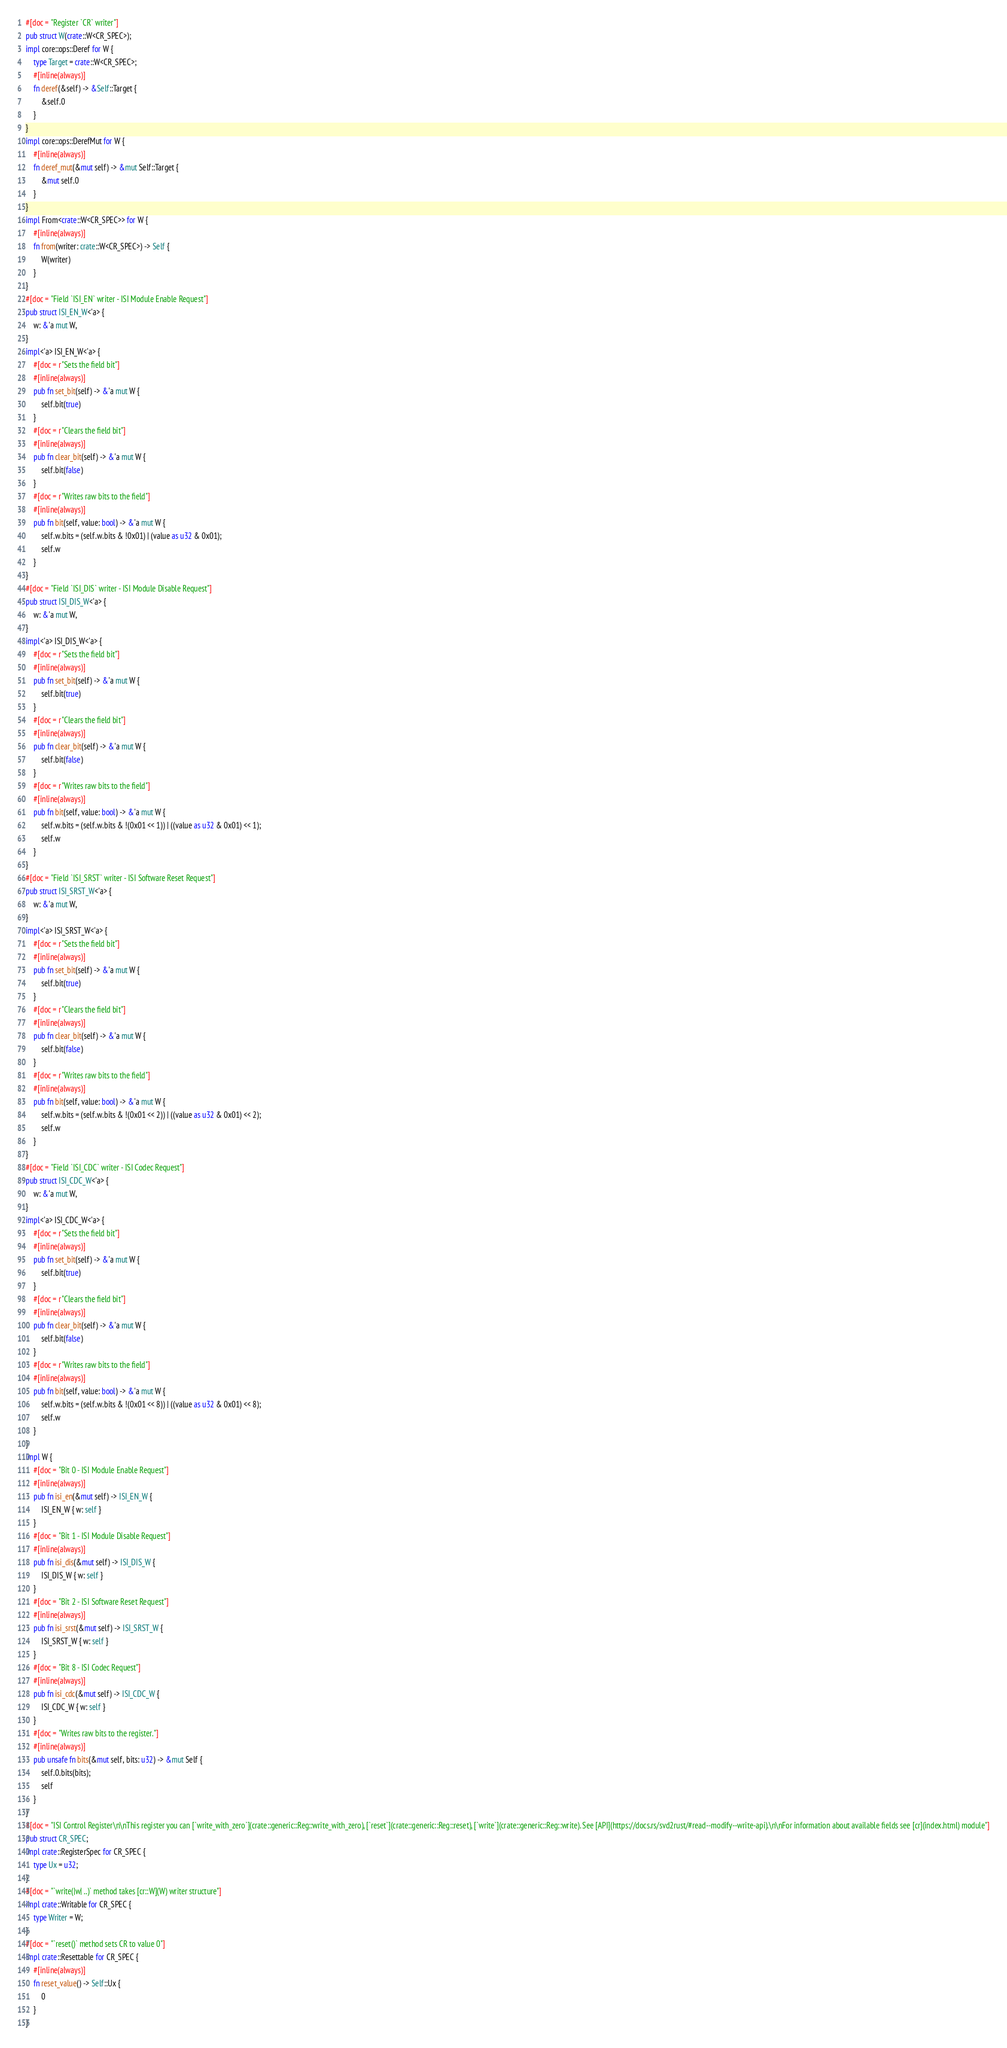<code> <loc_0><loc_0><loc_500><loc_500><_Rust_>#[doc = "Register `CR` writer"]
pub struct W(crate::W<CR_SPEC>);
impl core::ops::Deref for W {
    type Target = crate::W<CR_SPEC>;
    #[inline(always)]
    fn deref(&self) -> &Self::Target {
        &self.0
    }
}
impl core::ops::DerefMut for W {
    #[inline(always)]
    fn deref_mut(&mut self) -> &mut Self::Target {
        &mut self.0
    }
}
impl From<crate::W<CR_SPEC>> for W {
    #[inline(always)]
    fn from(writer: crate::W<CR_SPEC>) -> Self {
        W(writer)
    }
}
#[doc = "Field `ISI_EN` writer - ISI Module Enable Request"]
pub struct ISI_EN_W<'a> {
    w: &'a mut W,
}
impl<'a> ISI_EN_W<'a> {
    #[doc = r"Sets the field bit"]
    #[inline(always)]
    pub fn set_bit(self) -> &'a mut W {
        self.bit(true)
    }
    #[doc = r"Clears the field bit"]
    #[inline(always)]
    pub fn clear_bit(self) -> &'a mut W {
        self.bit(false)
    }
    #[doc = r"Writes raw bits to the field"]
    #[inline(always)]
    pub fn bit(self, value: bool) -> &'a mut W {
        self.w.bits = (self.w.bits & !0x01) | (value as u32 & 0x01);
        self.w
    }
}
#[doc = "Field `ISI_DIS` writer - ISI Module Disable Request"]
pub struct ISI_DIS_W<'a> {
    w: &'a mut W,
}
impl<'a> ISI_DIS_W<'a> {
    #[doc = r"Sets the field bit"]
    #[inline(always)]
    pub fn set_bit(self) -> &'a mut W {
        self.bit(true)
    }
    #[doc = r"Clears the field bit"]
    #[inline(always)]
    pub fn clear_bit(self) -> &'a mut W {
        self.bit(false)
    }
    #[doc = r"Writes raw bits to the field"]
    #[inline(always)]
    pub fn bit(self, value: bool) -> &'a mut W {
        self.w.bits = (self.w.bits & !(0x01 << 1)) | ((value as u32 & 0x01) << 1);
        self.w
    }
}
#[doc = "Field `ISI_SRST` writer - ISI Software Reset Request"]
pub struct ISI_SRST_W<'a> {
    w: &'a mut W,
}
impl<'a> ISI_SRST_W<'a> {
    #[doc = r"Sets the field bit"]
    #[inline(always)]
    pub fn set_bit(self) -> &'a mut W {
        self.bit(true)
    }
    #[doc = r"Clears the field bit"]
    #[inline(always)]
    pub fn clear_bit(self) -> &'a mut W {
        self.bit(false)
    }
    #[doc = r"Writes raw bits to the field"]
    #[inline(always)]
    pub fn bit(self, value: bool) -> &'a mut W {
        self.w.bits = (self.w.bits & !(0x01 << 2)) | ((value as u32 & 0x01) << 2);
        self.w
    }
}
#[doc = "Field `ISI_CDC` writer - ISI Codec Request"]
pub struct ISI_CDC_W<'a> {
    w: &'a mut W,
}
impl<'a> ISI_CDC_W<'a> {
    #[doc = r"Sets the field bit"]
    #[inline(always)]
    pub fn set_bit(self) -> &'a mut W {
        self.bit(true)
    }
    #[doc = r"Clears the field bit"]
    #[inline(always)]
    pub fn clear_bit(self) -> &'a mut W {
        self.bit(false)
    }
    #[doc = r"Writes raw bits to the field"]
    #[inline(always)]
    pub fn bit(self, value: bool) -> &'a mut W {
        self.w.bits = (self.w.bits & !(0x01 << 8)) | ((value as u32 & 0x01) << 8);
        self.w
    }
}
impl W {
    #[doc = "Bit 0 - ISI Module Enable Request"]
    #[inline(always)]
    pub fn isi_en(&mut self) -> ISI_EN_W {
        ISI_EN_W { w: self }
    }
    #[doc = "Bit 1 - ISI Module Disable Request"]
    #[inline(always)]
    pub fn isi_dis(&mut self) -> ISI_DIS_W {
        ISI_DIS_W { w: self }
    }
    #[doc = "Bit 2 - ISI Software Reset Request"]
    #[inline(always)]
    pub fn isi_srst(&mut self) -> ISI_SRST_W {
        ISI_SRST_W { w: self }
    }
    #[doc = "Bit 8 - ISI Codec Request"]
    #[inline(always)]
    pub fn isi_cdc(&mut self) -> ISI_CDC_W {
        ISI_CDC_W { w: self }
    }
    #[doc = "Writes raw bits to the register."]
    #[inline(always)]
    pub unsafe fn bits(&mut self, bits: u32) -> &mut Self {
        self.0.bits(bits);
        self
    }
}
#[doc = "ISI Control Register\n\nThis register you can [`write_with_zero`](crate::generic::Reg::write_with_zero), [`reset`](crate::generic::Reg::reset), [`write`](crate::generic::Reg::write). See [API](https://docs.rs/svd2rust/#read--modify--write-api).\n\nFor information about available fields see [cr](index.html) module"]
pub struct CR_SPEC;
impl crate::RegisterSpec for CR_SPEC {
    type Ux = u32;
}
#[doc = "`write(|w| ..)` method takes [cr::W](W) writer structure"]
impl crate::Writable for CR_SPEC {
    type Writer = W;
}
#[doc = "`reset()` method sets CR to value 0"]
impl crate::Resettable for CR_SPEC {
    #[inline(always)]
    fn reset_value() -> Self::Ux {
        0
    }
}
</code> 